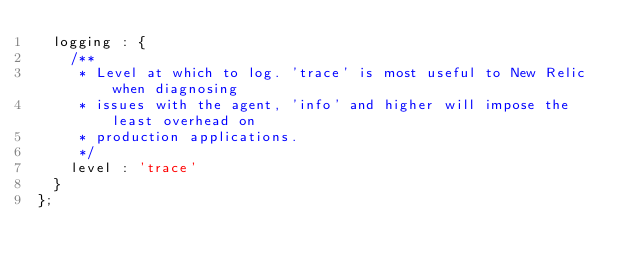Convert code to text. <code><loc_0><loc_0><loc_500><loc_500><_JavaScript_>  logging : {
    /**
     * Level at which to log. 'trace' is most useful to New Relic when diagnosing
     * issues with the agent, 'info' and higher will impose the least overhead on
     * production applications.
     */
    level : 'trace'
  }
};
</code> 